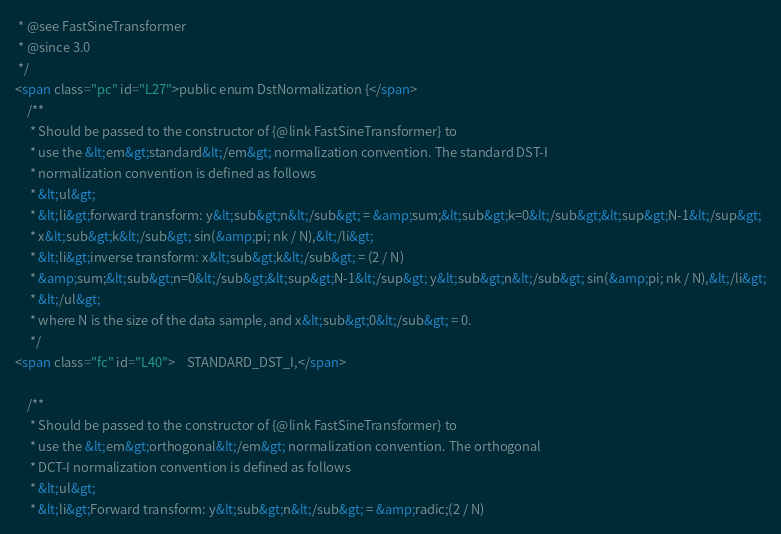Convert code to text. <code><loc_0><loc_0><loc_500><loc_500><_HTML_> * @see FastSineTransformer
 * @since 3.0
 */
<span class="pc" id="L27">public enum DstNormalization {</span>
    /**
     * Should be passed to the constructor of {@link FastSineTransformer} to
     * use the &lt;em&gt;standard&lt;/em&gt; normalization convention. The standard DST-I
     * normalization convention is defined as follows
     * &lt;ul&gt;
     * &lt;li&gt;forward transform: y&lt;sub&gt;n&lt;/sub&gt; = &amp;sum;&lt;sub&gt;k=0&lt;/sub&gt;&lt;sup&gt;N-1&lt;/sup&gt;
     * x&lt;sub&gt;k&lt;/sub&gt; sin(&amp;pi; nk / N),&lt;/li&gt;
     * &lt;li&gt;inverse transform: x&lt;sub&gt;k&lt;/sub&gt; = (2 / N)
     * &amp;sum;&lt;sub&gt;n=0&lt;/sub&gt;&lt;sup&gt;N-1&lt;/sup&gt; y&lt;sub&gt;n&lt;/sub&gt; sin(&amp;pi; nk / N),&lt;/li&gt;
     * &lt;/ul&gt;
     * where N is the size of the data sample, and x&lt;sub&gt;0&lt;/sub&gt; = 0.
     */
<span class="fc" id="L40">    STANDARD_DST_I,</span>

    /**
     * Should be passed to the constructor of {@link FastSineTransformer} to
     * use the &lt;em&gt;orthogonal&lt;/em&gt; normalization convention. The orthogonal
     * DCT-I normalization convention is defined as follows
     * &lt;ul&gt;
     * &lt;li&gt;Forward transform: y&lt;sub&gt;n&lt;/sub&gt; = &amp;radic;(2 / N)</code> 